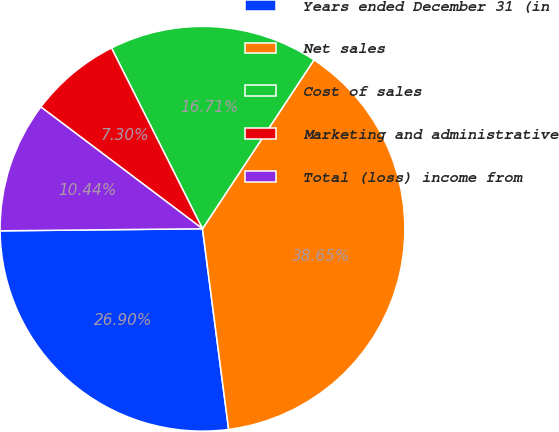Convert chart. <chart><loc_0><loc_0><loc_500><loc_500><pie_chart><fcel>Years ended December 31 (in<fcel>Net sales<fcel>Cost of sales<fcel>Marketing and administrative<fcel>Total (loss) income from<nl><fcel>26.9%<fcel>38.65%<fcel>16.71%<fcel>7.3%<fcel>10.44%<nl></chart> 